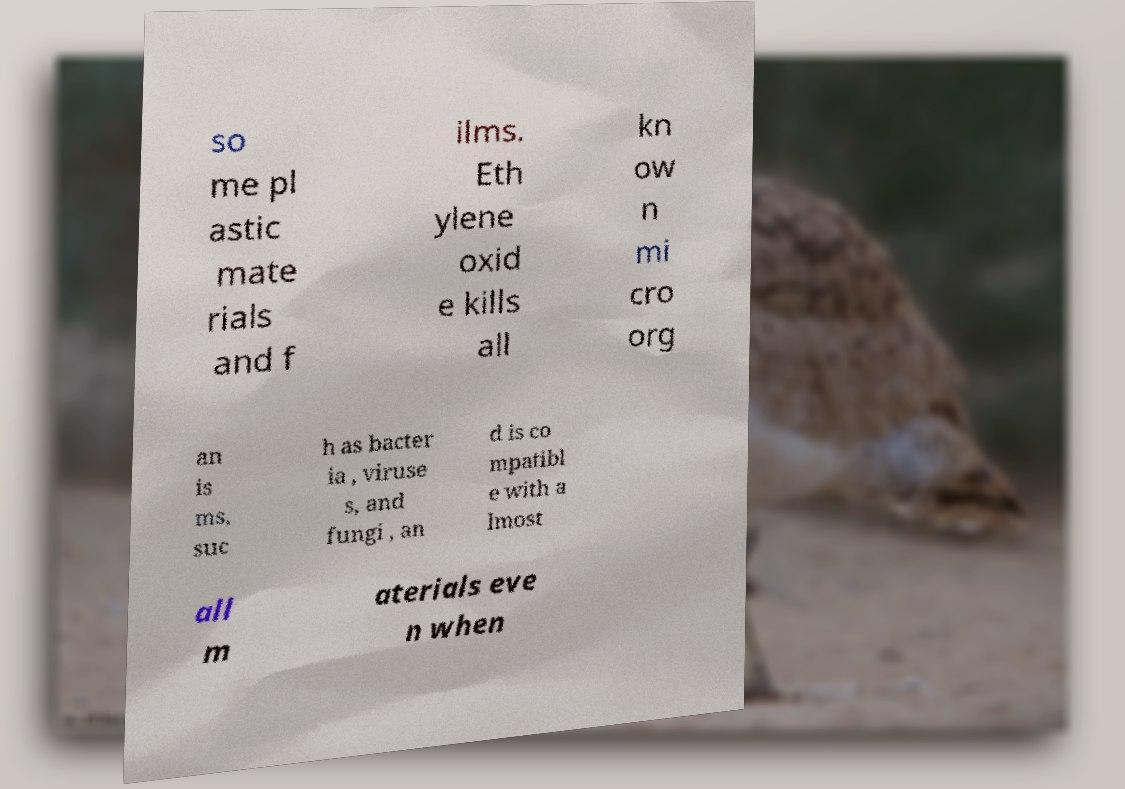I need the written content from this picture converted into text. Can you do that? so me pl astic mate rials and f ilms. Eth ylene oxid e kills all kn ow n mi cro org an is ms, suc h as bacter ia , viruse s, and fungi , an d is co mpatibl e with a lmost all m aterials eve n when 